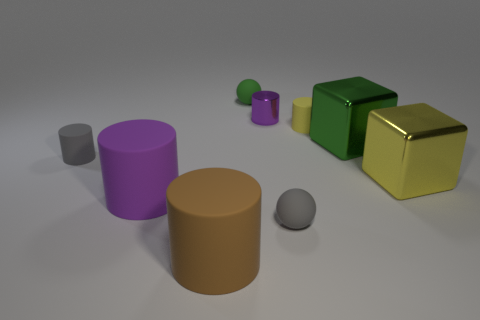Subtract all gray cylinders. How many cylinders are left? 4 Subtract all brown cylinders. How many cylinders are left? 4 Subtract all green cylinders. Subtract all purple blocks. How many cylinders are left? 5 Add 1 yellow metallic objects. How many objects exist? 10 Subtract all cylinders. How many objects are left? 4 Add 2 small gray things. How many small gray things are left? 4 Add 9 small yellow things. How many small yellow things exist? 10 Subtract 1 brown cylinders. How many objects are left? 8 Subtract all small green spheres. Subtract all big brown rubber things. How many objects are left? 7 